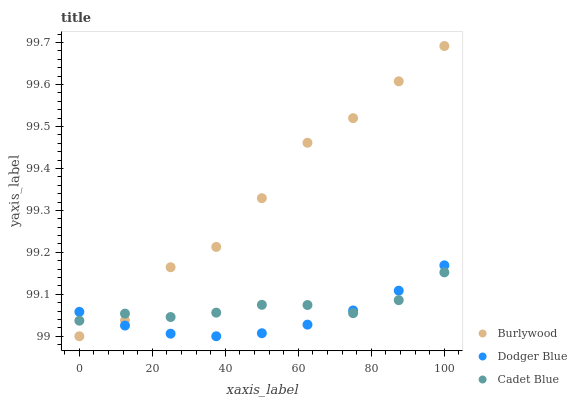Does Dodger Blue have the minimum area under the curve?
Answer yes or no. Yes. Does Burlywood have the maximum area under the curve?
Answer yes or no. Yes. Does Cadet Blue have the minimum area under the curve?
Answer yes or no. No. Does Cadet Blue have the maximum area under the curve?
Answer yes or no. No. Is Dodger Blue the smoothest?
Answer yes or no. Yes. Is Burlywood the roughest?
Answer yes or no. Yes. Is Cadet Blue the smoothest?
Answer yes or no. No. Is Cadet Blue the roughest?
Answer yes or no. No. Does Burlywood have the lowest value?
Answer yes or no. Yes. Does Dodger Blue have the lowest value?
Answer yes or no. No. Does Burlywood have the highest value?
Answer yes or no. Yes. Does Dodger Blue have the highest value?
Answer yes or no. No. Does Cadet Blue intersect Burlywood?
Answer yes or no. Yes. Is Cadet Blue less than Burlywood?
Answer yes or no. No. Is Cadet Blue greater than Burlywood?
Answer yes or no. No. 